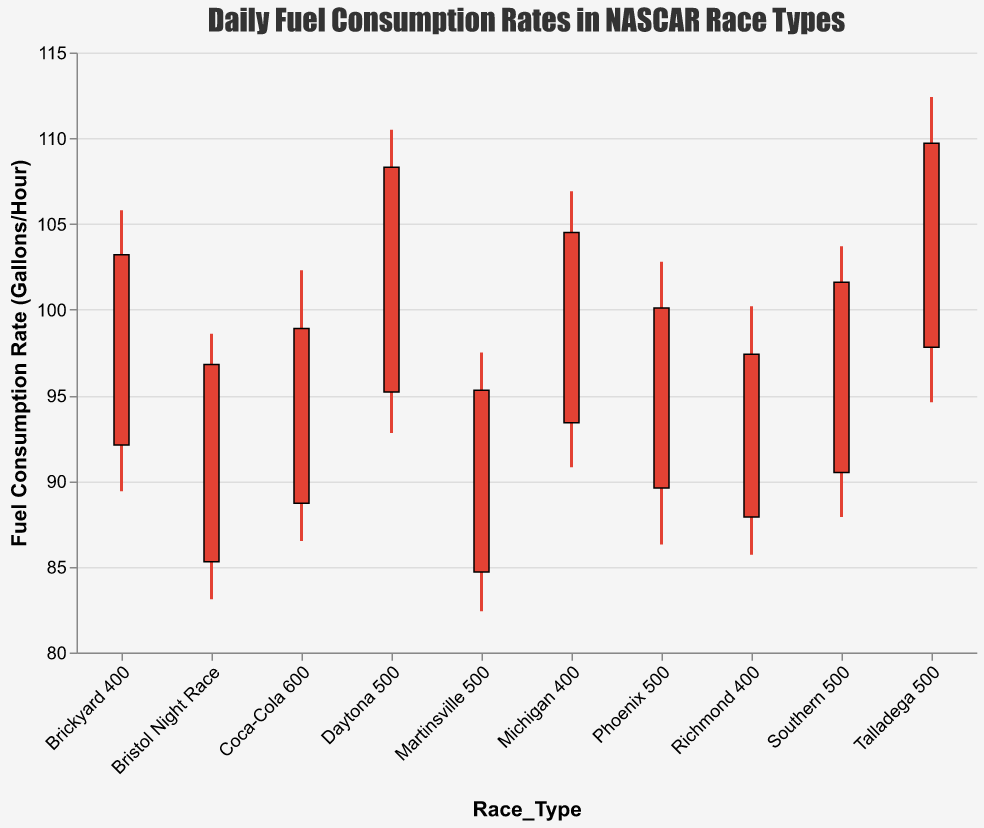What is the highest fuel consumption rate recorded across all race types? The highest fuel consumption rate can be found by looking at the "High" values for each race type. The maximum "High" value across all race types is 112.4.
Answer: 112.4 Which race type has the lowest opening fuel consumption rate? To find the lowest opening fuel consumption rate, compare the "Open" values for all the race types. The lowest "Open" value is 84.7, which corresponds to Martinsville 500.
Answer: Martinsville 500 What is the average closing fuel consumption rate across all race types? To find the average closing fuel consumption rate, sum all "Close" values and then divide by the number of race types. The sum of "Close" values is 1015.8, and there are 10 race types. So, the average is 1015.8 / 10 = 101.58.
Answer: 101.58 How does the closing fuel consumption rate for Bristol Night Race compare to the Talladega 500? To compare these two race types, look at their "Close" values. Bristol Night Race has a close of 96.8, and Talladega 500 has a close of 109.7. 109.7 is higher than 96.8.
Answer: Talladega 500 is higher Which race type has the largest range in fuel consumption rate? The range can be found by subtracting the "Low" value from the "High" value for each race type. The largest difference is Talladega 500, where the range is 112.4 - 94.6 = 17.8.
Answer: Talladega 500 What is the median of the opening fuel consumption rates for all race types? To find the median, first list all "Open" values in increasing order: 84.7, 85.3, 87.9, 88.7, 89.6, 90.5, 92.1, 93.4, 95.2, 97.8. As there are 10 values, the median is the average of the 5th and 6th values, (89.6 + 90.5) / 2 = 90.05.
Answer: 90.05 What is the color used for the bars in the chart? The color used for the bars can be observed directly from the chart, and it is consistent for all bars. The bars are colored in a red hue.
Answer: Red How does the fuel consumption rate fluctuate within each race type? The fluctuation can be observed by the height of the vertical lines representing the "Low" and "High" values within each bar, indicating the range of fuel consumption rates for each race type. The fluctuation varies with each race, such as Talladega 500 having a high fluctuation and Martinsville 500 having a lower fluctuation.
Answer: Varies by race type What is the fuel consumption rate range for the Michigan 400? The range for Michigan 400 can be determined by subtracting the "Low" value from the "High" value. The values are 106.9 (High) and 90.8 (Low), giving a range of 106.9 - 90.8 = 16.1.
Answer: 16.1 Which race type closes at a value lower than its opening value? By comparing "Open" and "Close" values for each race type, Bristol Night Race has an opening value of 85.3 and closes at 96.8, and Martinsville 500 has an opening value of 84.7 and closes at 95.3. All other race types have closing values higher than their opening values, so these two are exceptions.
Answer: Bristol Night Race and Martinsville 500 